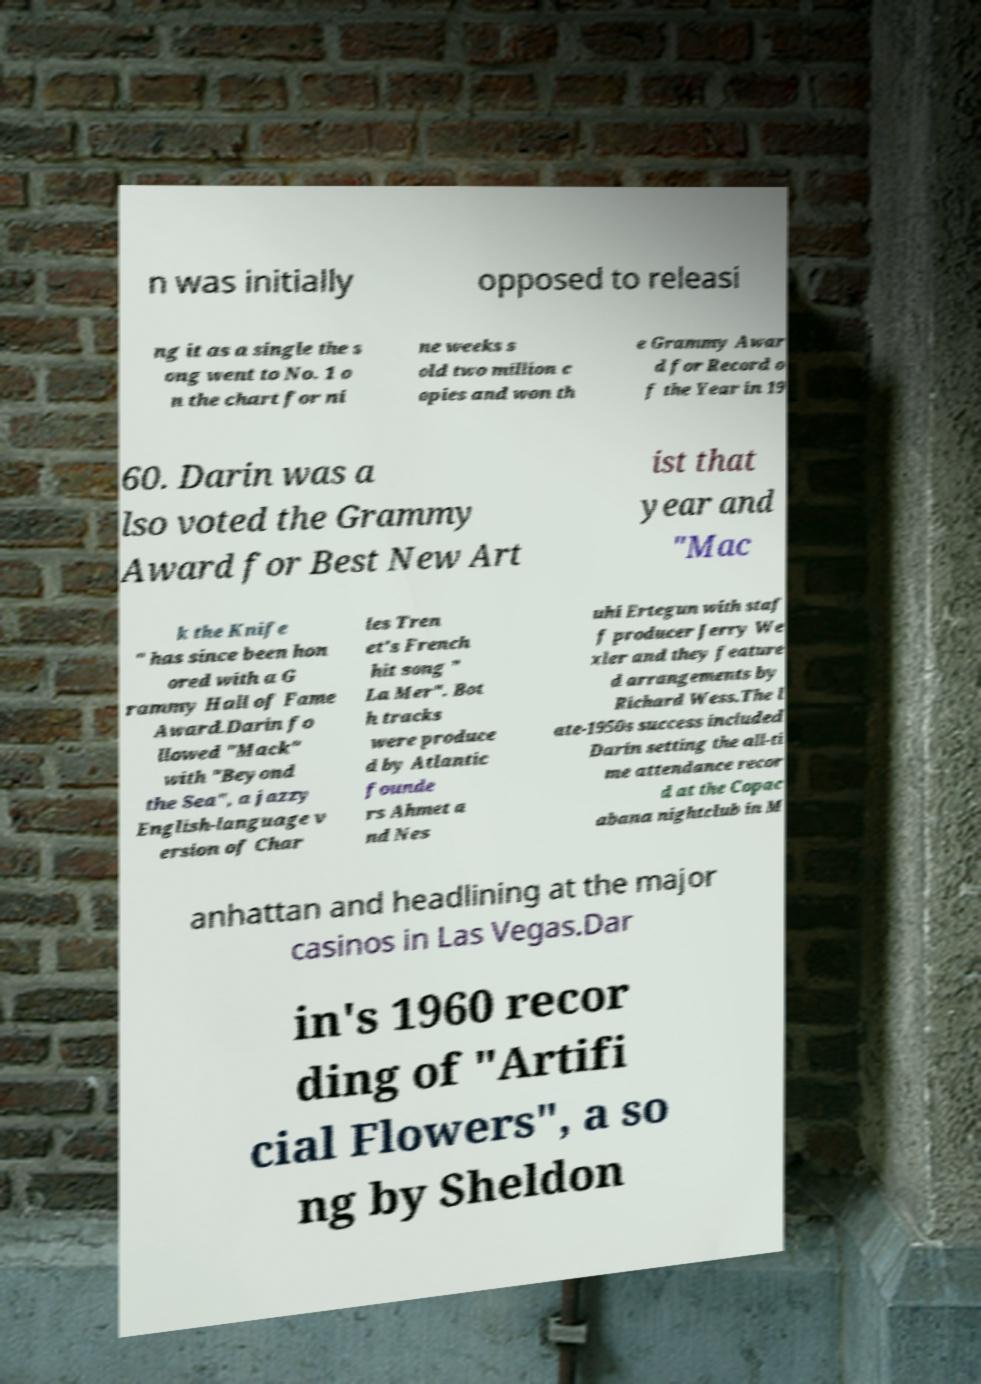Please read and relay the text visible in this image. What does it say? n was initially opposed to releasi ng it as a single the s ong went to No. 1 o n the chart for ni ne weeks s old two million c opies and won th e Grammy Awar d for Record o f the Year in 19 60. Darin was a lso voted the Grammy Award for Best New Art ist that year and "Mac k the Knife " has since been hon ored with a G rammy Hall of Fame Award.Darin fo llowed "Mack" with "Beyond the Sea", a jazzy English-language v ersion of Char les Tren et's French hit song " La Mer". Bot h tracks were produce d by Atlantic founde rs Ahmet a nd Nes uhi Ertegun with staf f producer Jerry We xler and they feature d arrangements by Richard Wess.The l ate-1950s success included Darin setting the all-ti me attendance recor d at the Copac abana nightclub in M anhattan and headlining at the major casinos in Las Vegas.Dar in's 1960 recor ding of "Artifi cial Flowers", a so ng by Sheldon 